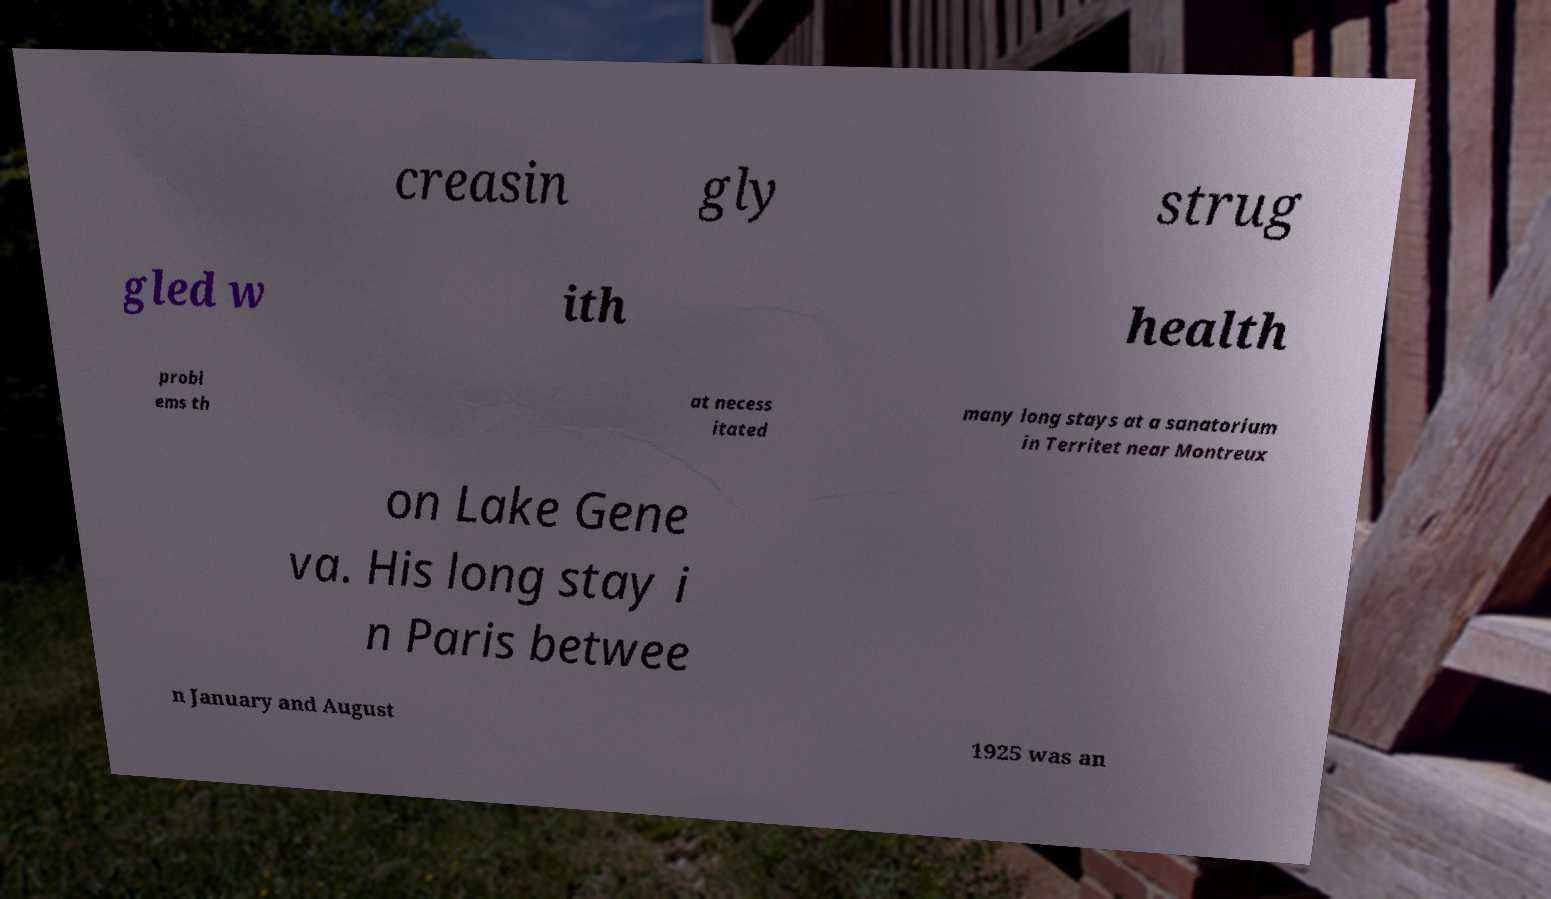I need the written content from this picture converted into text. Can you do that? creasin gly strug gled w ith health probl ems th at necess itated many long stays at a sanatorium in Territet near Montreux on Lake Gene va. His long stay i n Paris betwee n January and August 1925 was an 